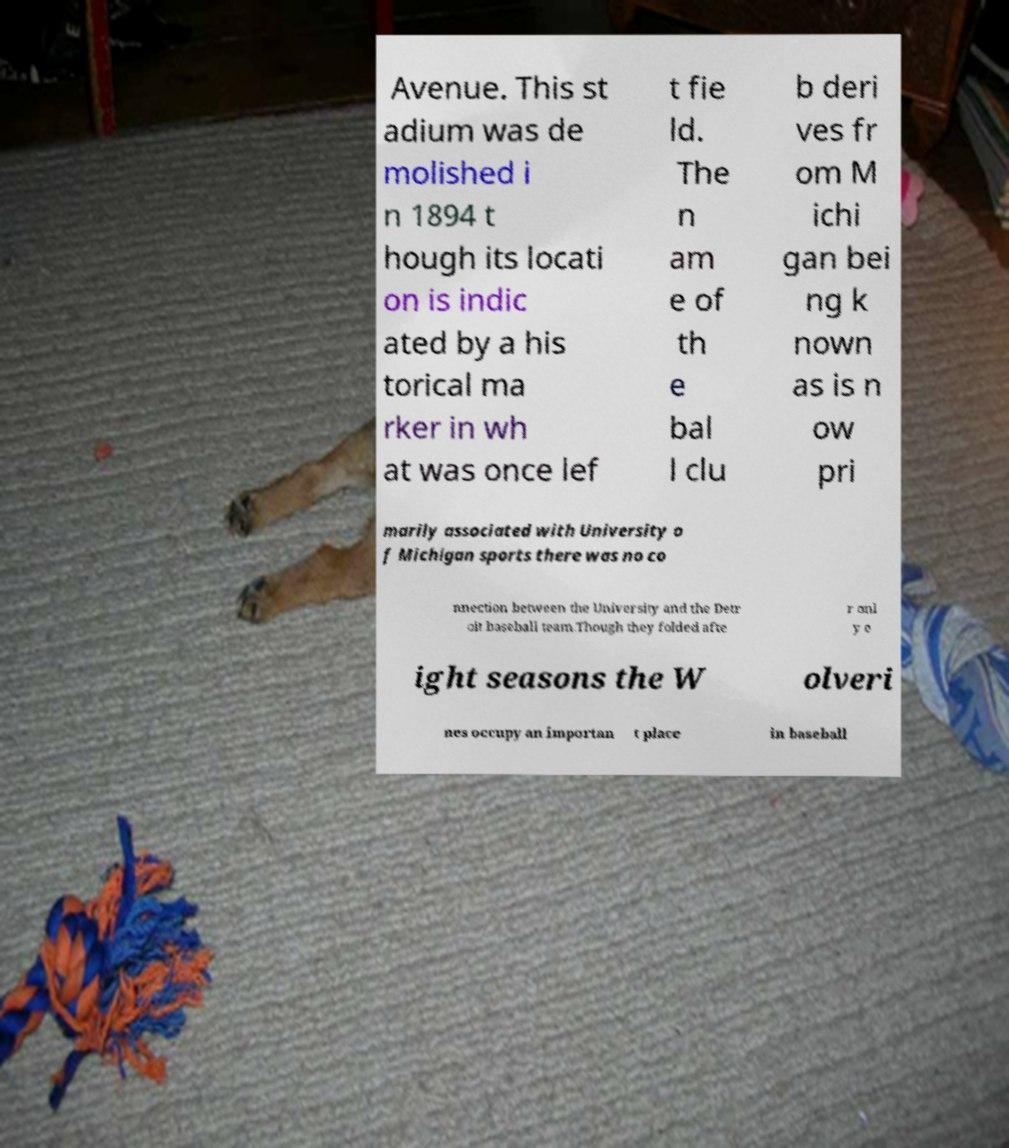There's text embedded in this image that I need extracted. Can you transcribe it verbatim? Avenue. This st adium was de molished i n 1894 t hough its locati on is indic ated by a his torical ma rker in wh at was once lef t fie ld. The n am e of th e bal l clu b deri ves fr om M ichi gan bei ng k nown as is n ow pri marily associated with University o f Michigan sports there was no co nnection between the University and the Detr oit baseball team.Though they folded afte r onl y e ight seasons the W olveri nes occupy an importan t place in baseball 